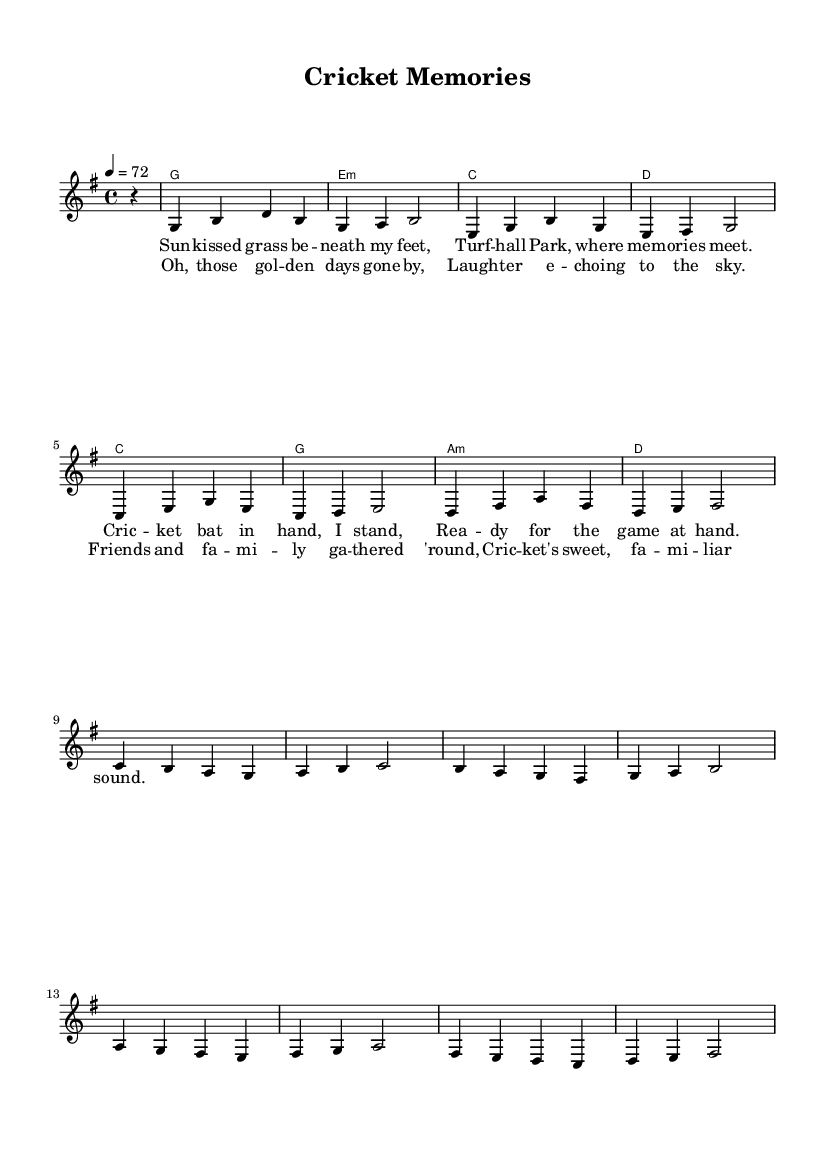What is the key signature of this music? The key signature is based on the note G major, which has one sharp (F#). You can determine the key signature by looking at the beginning of the staff where sharps or flats are indicated.
Answer: G major What is the time signature of this piece? The time signature is indicated at the beginning of the staff, reading as "4/4." This means there are four beats in a measure, with a quarter note receiving one beat.
Answer: 4/4 What is the tempo marking for this score? The tempo is notated as "4 = 72" at the beginning of the music, meaning that the quarter note is equal to 72 beats per minute.
Answer: 72 How many measures are in the melody? To find the number of measures in the melody, count the individual groupings of notes separated by bar lines. The melody has 16 measures in total.
Answer: 16 Which chord follows the G major chord in the harmony? By looking at the chord mode and following the sequence of chords, the chord that follows the G major is E minor. This is identified by seeing the order in which the chords are written down.
Answer: E minor What lyrical theme is depicted in the verse? The verses reflect nostalgic memories of playing cricket and enjoying time at Turfhall Park. By reading the lines of the verse carefully, it is clear that it describes fond memories related to cricket.
Answer: Nostalgia What is the structure of the song in terms of sections? The structure has a verse followed by a chorus, which is a common format in pop music. By identifying the sections labeled for lyrics, it is evident that the song alternates between these two distinct parts.
Answer: Verse and chorus 